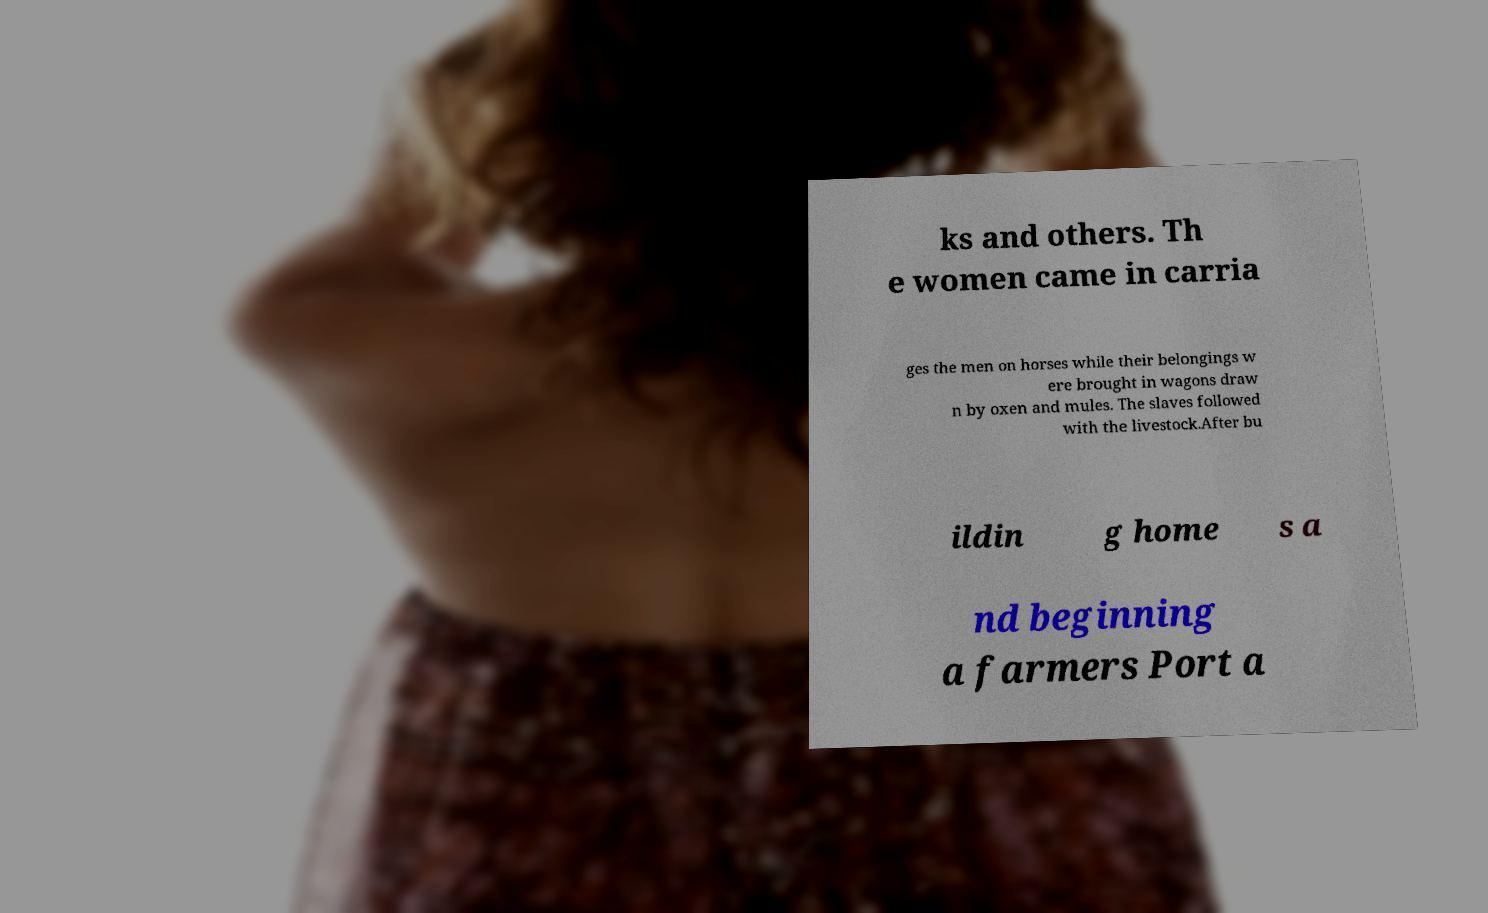There's text embedded in this image that I need extracted. Can you transcribe it verbatim? ks and others. Th e women came in carria ges the men on horses while their belongings w ere brought in wagons draw n by oxen and mules. The slaves followed with the livestock.After bu ildin g home s a nd beginning a farmers Port a 